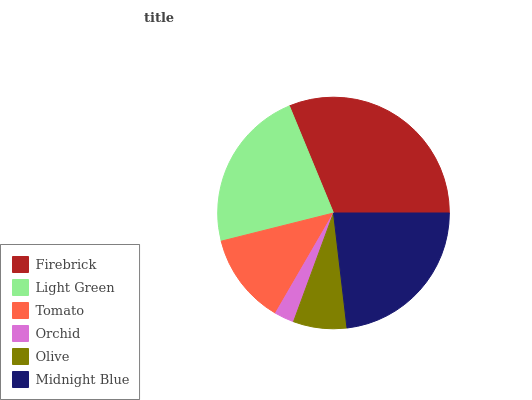Is Orchid the minimum?
Answer yes or no. Yes. Is Firebrick the maximum?
Answer yes or no. Yes. Is Light Green the minimum?
Answer yes or no. No. Is Light Green the maximum?
Answer yes or no. No. Is Firebrick greater than Light Green?
Answer yes or no. Yes. Is Light Green less than Firebrick?
Answer yes or no. Yes. Is Light Green greater than Firebrick?
Answer yes or no. No. Is Firebrick less than Light Green?
Answer yes or no. No. Is Light Green the high median?
Answer yes or no. Yes. Is Tomato the low median?
Answer yes or no. Yes. Is Firebrick the high median?
Answer yes or no. No. Is Olive the low median?
Answer yes or no. No. 